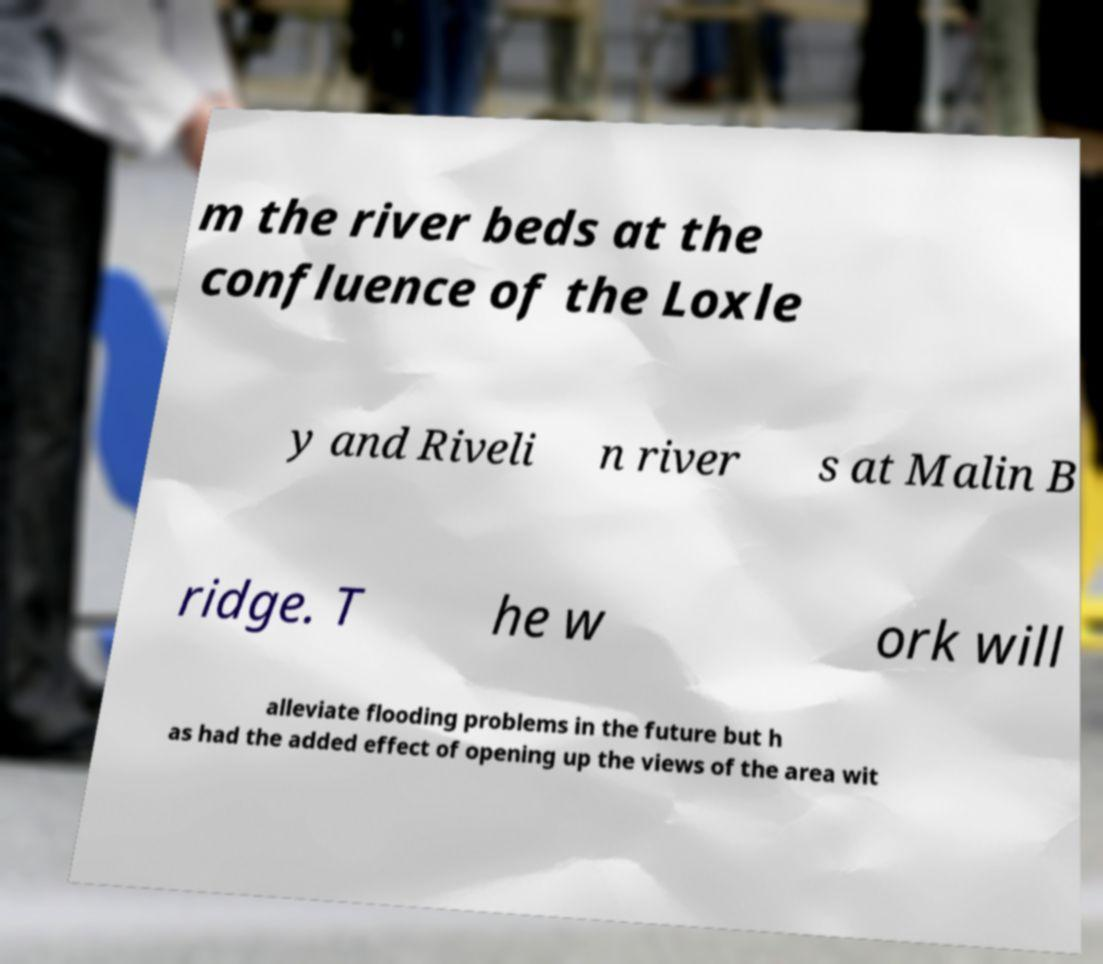I need the written content from this picture converted into text. Can you do that? m the river beds at the confluence of the Loxle y and Riveli n river s at Malin B ridge. T he w ork will alleviate flooding problems in the future but h as had the added effect of opening up the views of the area wit 